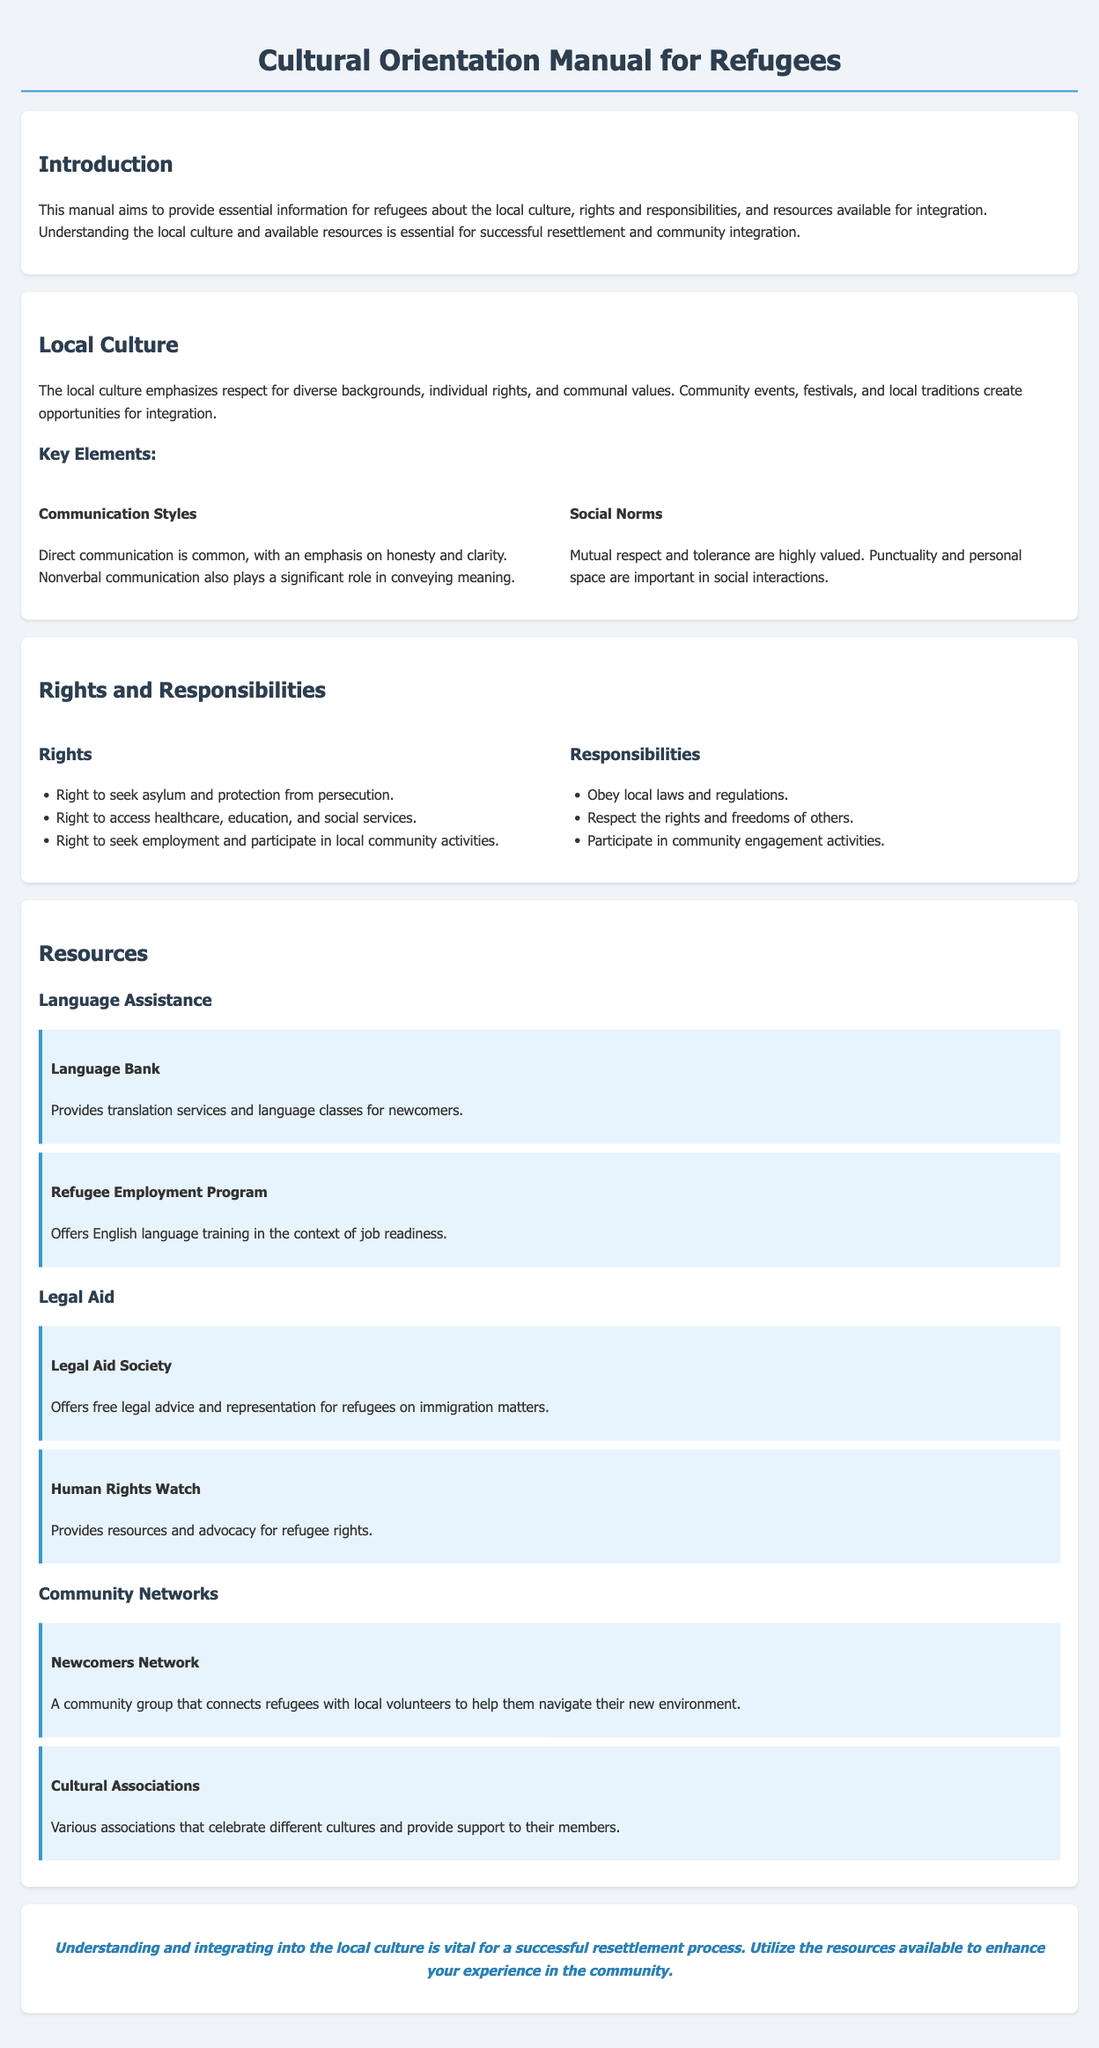What is the purpose of the manual? The manual aims to provide essential information for refugees about local culture, rights and responsibilities, and resources available for integration.
Answer: Provide essential information for refugees What are two key elements of local culture? The document highlights communication styles and social norms as key elements of local culture.
Answer: Communication styles, social norms What right do refugees have regarding healthcare? The document specifies that one of the rights includes access to healthcare.
Answer: Access to healthcare What is one responsibility of refugees mentioned in the manual? The manual states that refugees have the responsibility to obey local laws and regulations.
Answer: Obey local laws Which organization offers free legal advice for refugees? The "Legal Aid Society" is mentioned in the resources section as providing free legal advice for refugees.
Answer: Legal Aid Society What network connects refugees with local volunteers? The "Newcomers Network" connects refugees with local volunteers.
Answer: Newcomers Network How many rights are listed in the document? The document lists three specific rights for refugees.
Answer: Three What type of assistance does the Refugee Employment Program provide? The program offers English language training in the context of job readiness.
Answer: English language training Which cultural element is emphasized in social interactions? The importance of mutual respect and tolerance is emphasized in social interactions.
Answer: Mutual respect and tolerance 